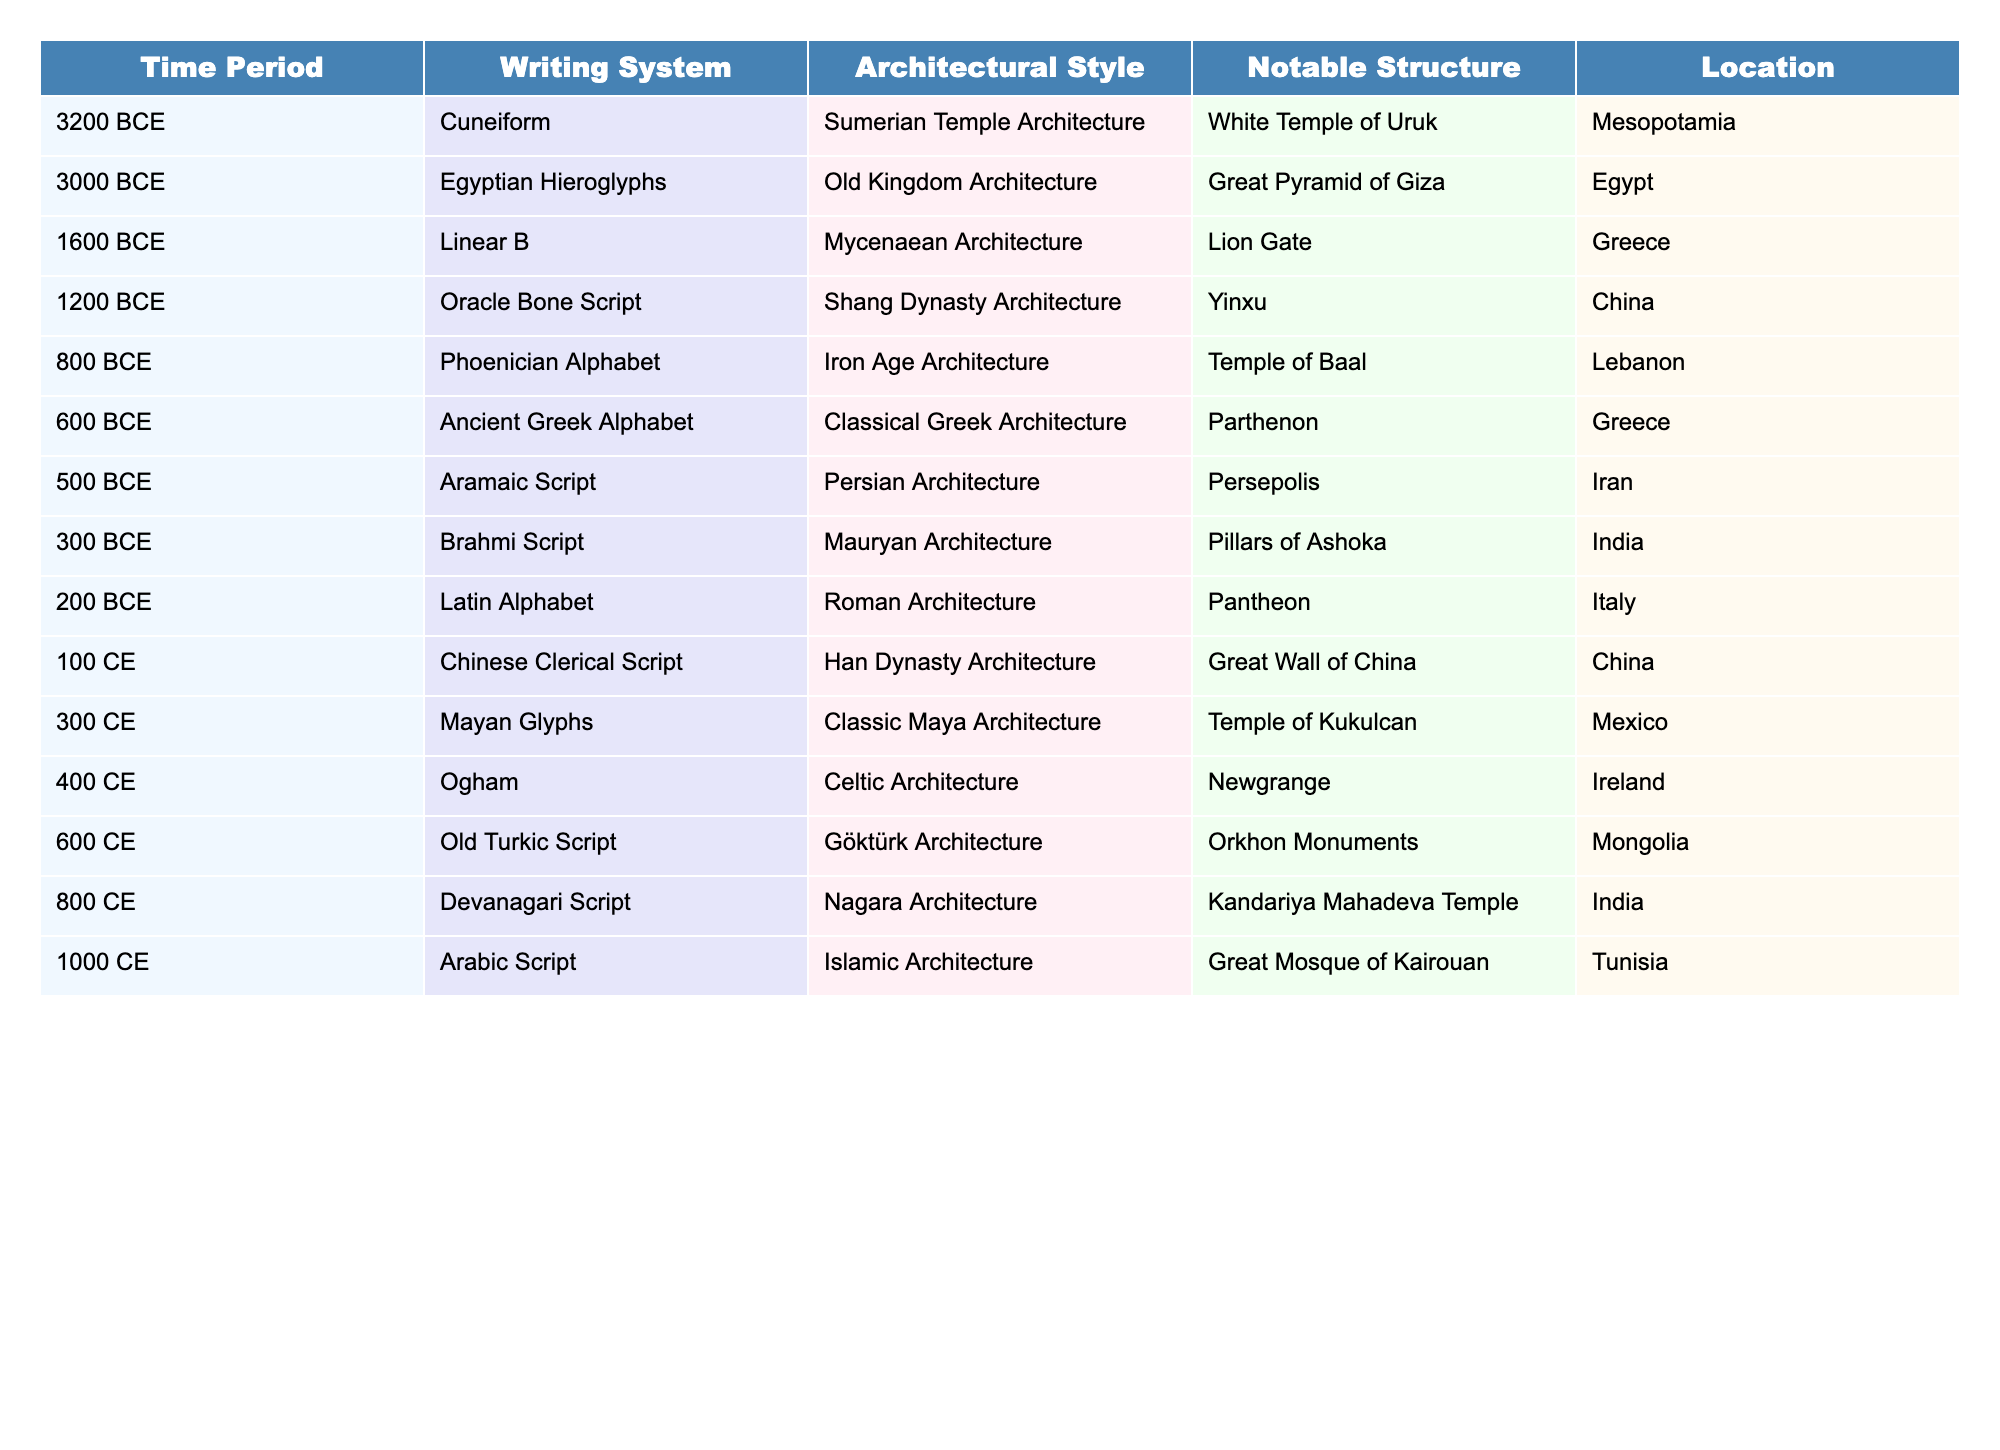What writing system corresponds to the Great Pyramid of Giza? By examining the table, I can see that the Great Pyramid of Giza, located in Egypt, corresponds to the writing system known as Egyptian Hieroglyphs, which is listed in the same row.
Answer: Egyptian Hieroglyphs Which architectural style was prevalent during the time of the Sumerian writing system? I look at the row for the Sumerian writing system (Cuneiform), and it is associated with Sumerian Temple Architecture.
Answer: Sumerian Temple Architecture What is the notable structure associated with the Linear B writing system? The table shows that the notable structure related to Linear B is the Lion Gate, as mentioned in the same row.
Answer: Lion Gate How many writing systems are associated with Indian architecture? The table contains references to two writing systems linked to Indian architecture: Brahmi Script and Devanagari Script. Thus, they are counted together.
Answer: 2 True or False: The Old Turkic Script was used in a structure called the Great Wall of China. By reviewing the table, I find that the Old Turkic Script is associated with the Orkhon Monuments, not the Great Wall of China, which corresponds to the Chinese Clerical Script.
Answer: False Which writing system is linked to the Temple of Kukulcan? According to the table, the writing system associated with the Temple of Kukulcan is Mayan Glyphs, found in the corresponding row.
Answer: Mayan Glyphs Which architectural styles were prevalent before 500 CE? I will examine the rows up to 500 CE: Sumerian Temple Architecture, Old Kingdom Architecture, Mycenaean Architecture, Shang Dynasty Architecture, Iron Age Architecture, Classical Greek Architecture, and Persian Architecture. This is a total of seven distinct styles.
Answer: 7 List the locations associated with the Brahmi Script and the Latin Alphabet. I look for the rows containing Brahmi Script and Latin Alphabet: Brahmi Script is linked to India, and Latin Alphabet is connected to Italy. I present both locations together.
Answer: India, Italy What is the time difference between the Oracle Bone Script and Arabic Script? The time for Oracle Bone Script is 1200 BCE, and Arabic Script is from 1000 CE. Calculating the difference involves converting BCE to CE: 1200 + 1000 = 2200 years apart.
Answer: 2200 years Which architectural styles are associated with writing systems developed in the first millennium CE? Referring to the table, I find that writing systems developed in the first millennium CE include the Chinese Clerical Script (Han Dynasty Architecture), Mayan Glyphs (Classic Maya Architecture), Ogham (Celtic Architecture), Old Turkic Script (Göktürk Architecture), and Arabic Script (Islamic Architecture). There are five styles.
Answer: 5 